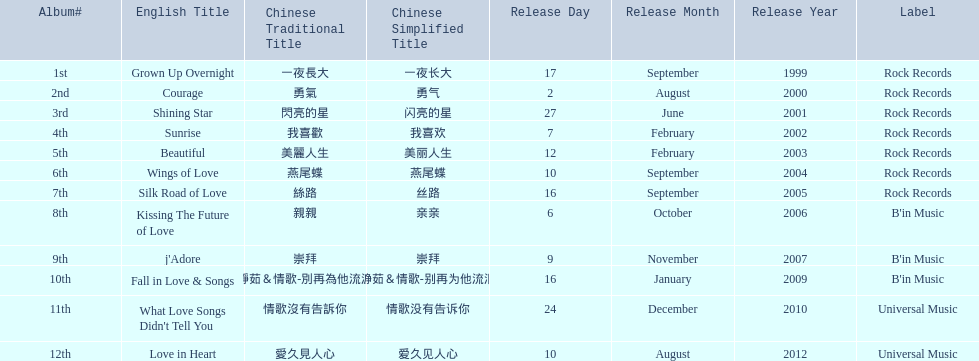What were the albums? Grown Up Overnight, Courage, Shining Star, Sunrise, Beautiful, Wings of Love, Silk Road of Love, Kissing The Future of Love, j'Adore, Fall in Love & Songs, What Love Songs Didn't Tell You, Love in Heart. Which ones were released by b'in music? Kissing The Future of Love, j'Adore. Of these, which one was in an even-numbered year? Kissing The Future of Love. 